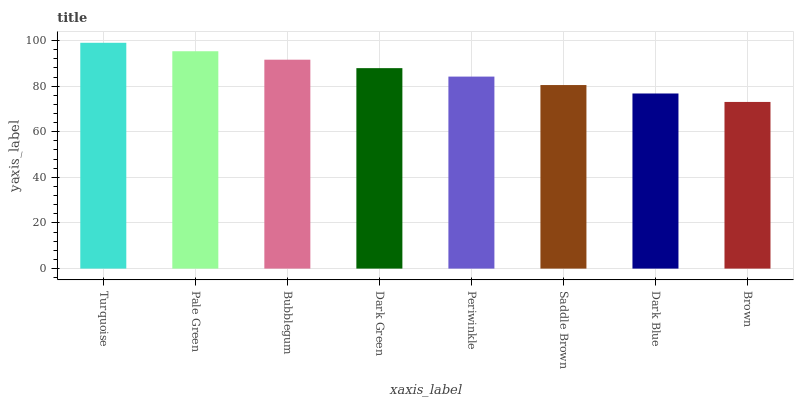Is Brown the minimum?
Answer yes or no. Yes. Is Turquoise the maximum?
Answer yes or no. Yes. Is Pale Green the minimum?
Answer yes or no. No. Is Pale Green the maximum?
Answer yes or no. No. Is Turquoise greater than Pale Green?
Answer yes or no. Yes. Is Pale Green less than Turquoise?
Answer yes or no. Yes. Is Pale Green greater than Turquoise?
Answer yes or no. No. Is Turquoise less than Pale Green?
Answer yes or no. No. Is Dark Green the high median?
Answer yes or no. Yes. Is Periwinkle the low median?
Answer yes or no. Yes. Is Turquoise the high median?
Answer yes or no. No. Is Pale Green the low median?
Answer yes or no. No. 